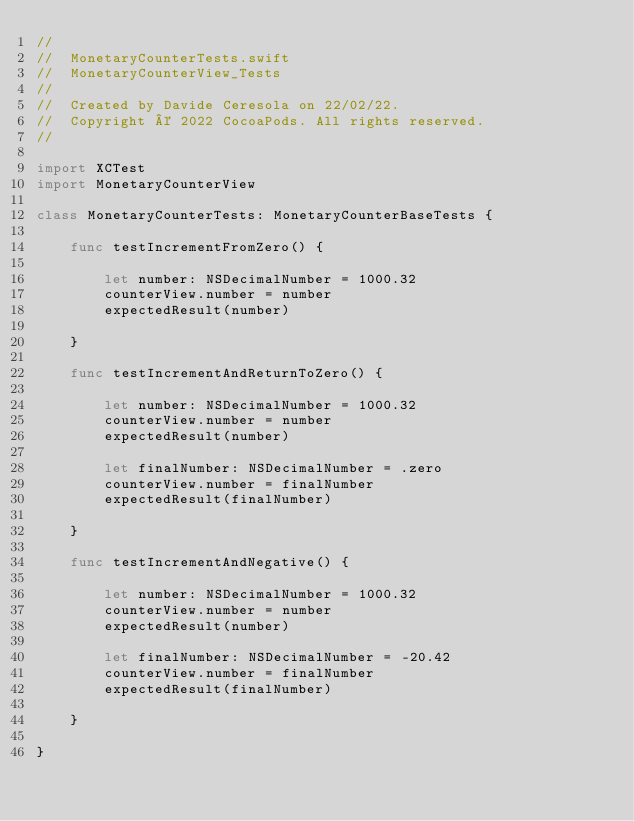<code> <loc_0><loc_0><loc_500><loc_500><_Swift_>//
//  MonetaryCounterTests.swift
//  MonetaryCounterView_Tests
//
//  Created by Davide Ceresola on 22/02/22.
//  Copyright © 2022 CocoaPods. All rights reserved.
//

import XCTest
import MonetaryCounterView

class MonetaryCounterTests: MonetaryCounterBaseTests {
    
    func testIncrementFromZero() {
        
        let number: NSDecimalNumber = 1000.32
        counterView.number = number
        expectedResult(number)
        
    }
    
    func testIncrementAndReturnToZero() {
        
        let number: NSDecimalNumber = 1000.32
        counterView.number = number
        expectedResult(number)
        
        let finalNumber: NSDecimalNumber = .zero
        counterView.number = finalNumber
        expectedResult(finalNumber)
        
    }
    
    func testIncrementAndNegative() {
        
        let number: NSDecimalNumber = 1000.32
        counterView.number = number
        expectedResult(number)
        
        let finalNumber: NSDecimalNumber = -20.42
        counterView.number = finalNumber
        expectedResult(finalNumber)
        
    }
    
}
</code> 